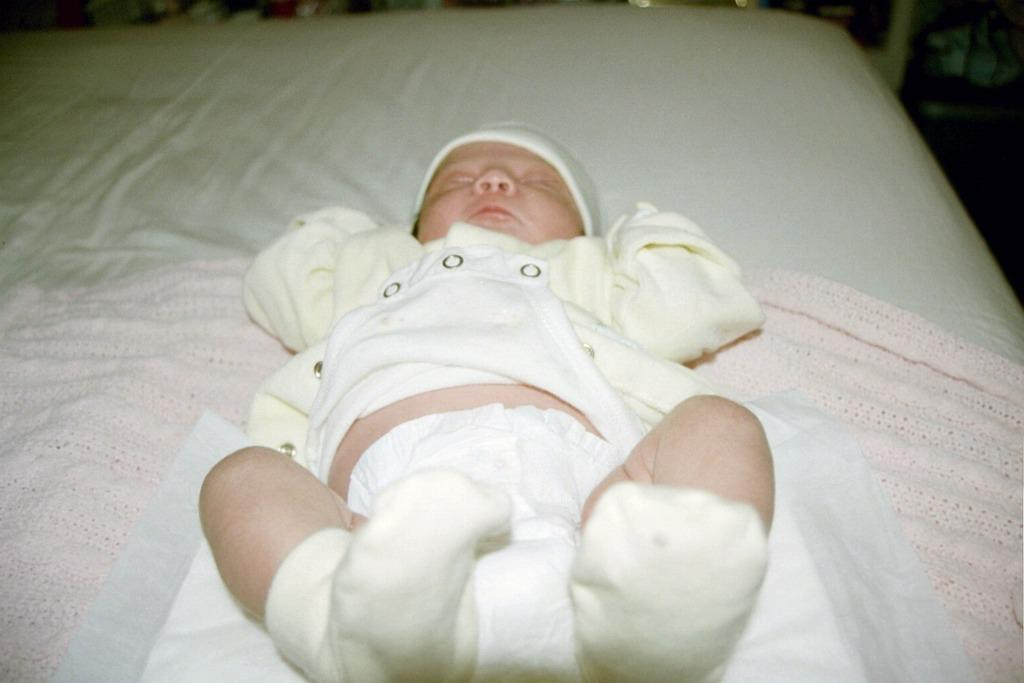What is the main subject of the image? There is a baby in the image. Where is the baby located? The baby is on a couch. What color is the cloth on the couch? The cloth on the couch is pink. What is the baby wearing on their head? The baby is wearing a cap. What type of riddle is the baby solving in the image? There is no riddle present in the image, and the baby is not solving any riddle. 